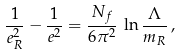<formula> <loc_0><loc_0><loc_500><loc_500>\frac { 1 } { e _ { R } ^ { 2 } } - \frac { 1 } { e ^ { 2 } } = \frac { N _ { f } } { 6 \pi ^ { 2 } } \, \ln \frac { \Lambda } { m _ { R } } \, ,</formula> 